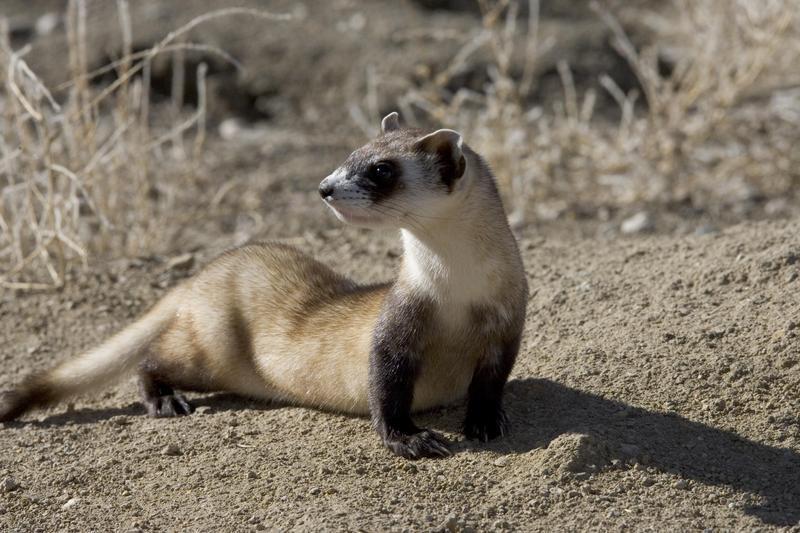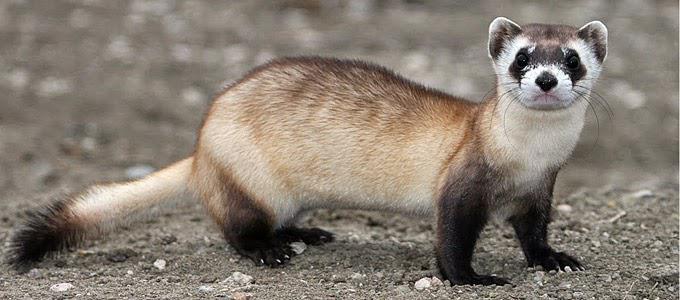The first image is the image on the left, the second image is the image on the right. For the images shown, is this caption "Each image contains one ferret standing on dirt ground, with at least one front and one back paw on the ground." true? Answer yes or no. Yes. The first image is the image on the left, the second image is the image on the right. For the images shown, is this caption "Both animals are standing on all fours on the ground." true? Answer yes or no. Yes. 